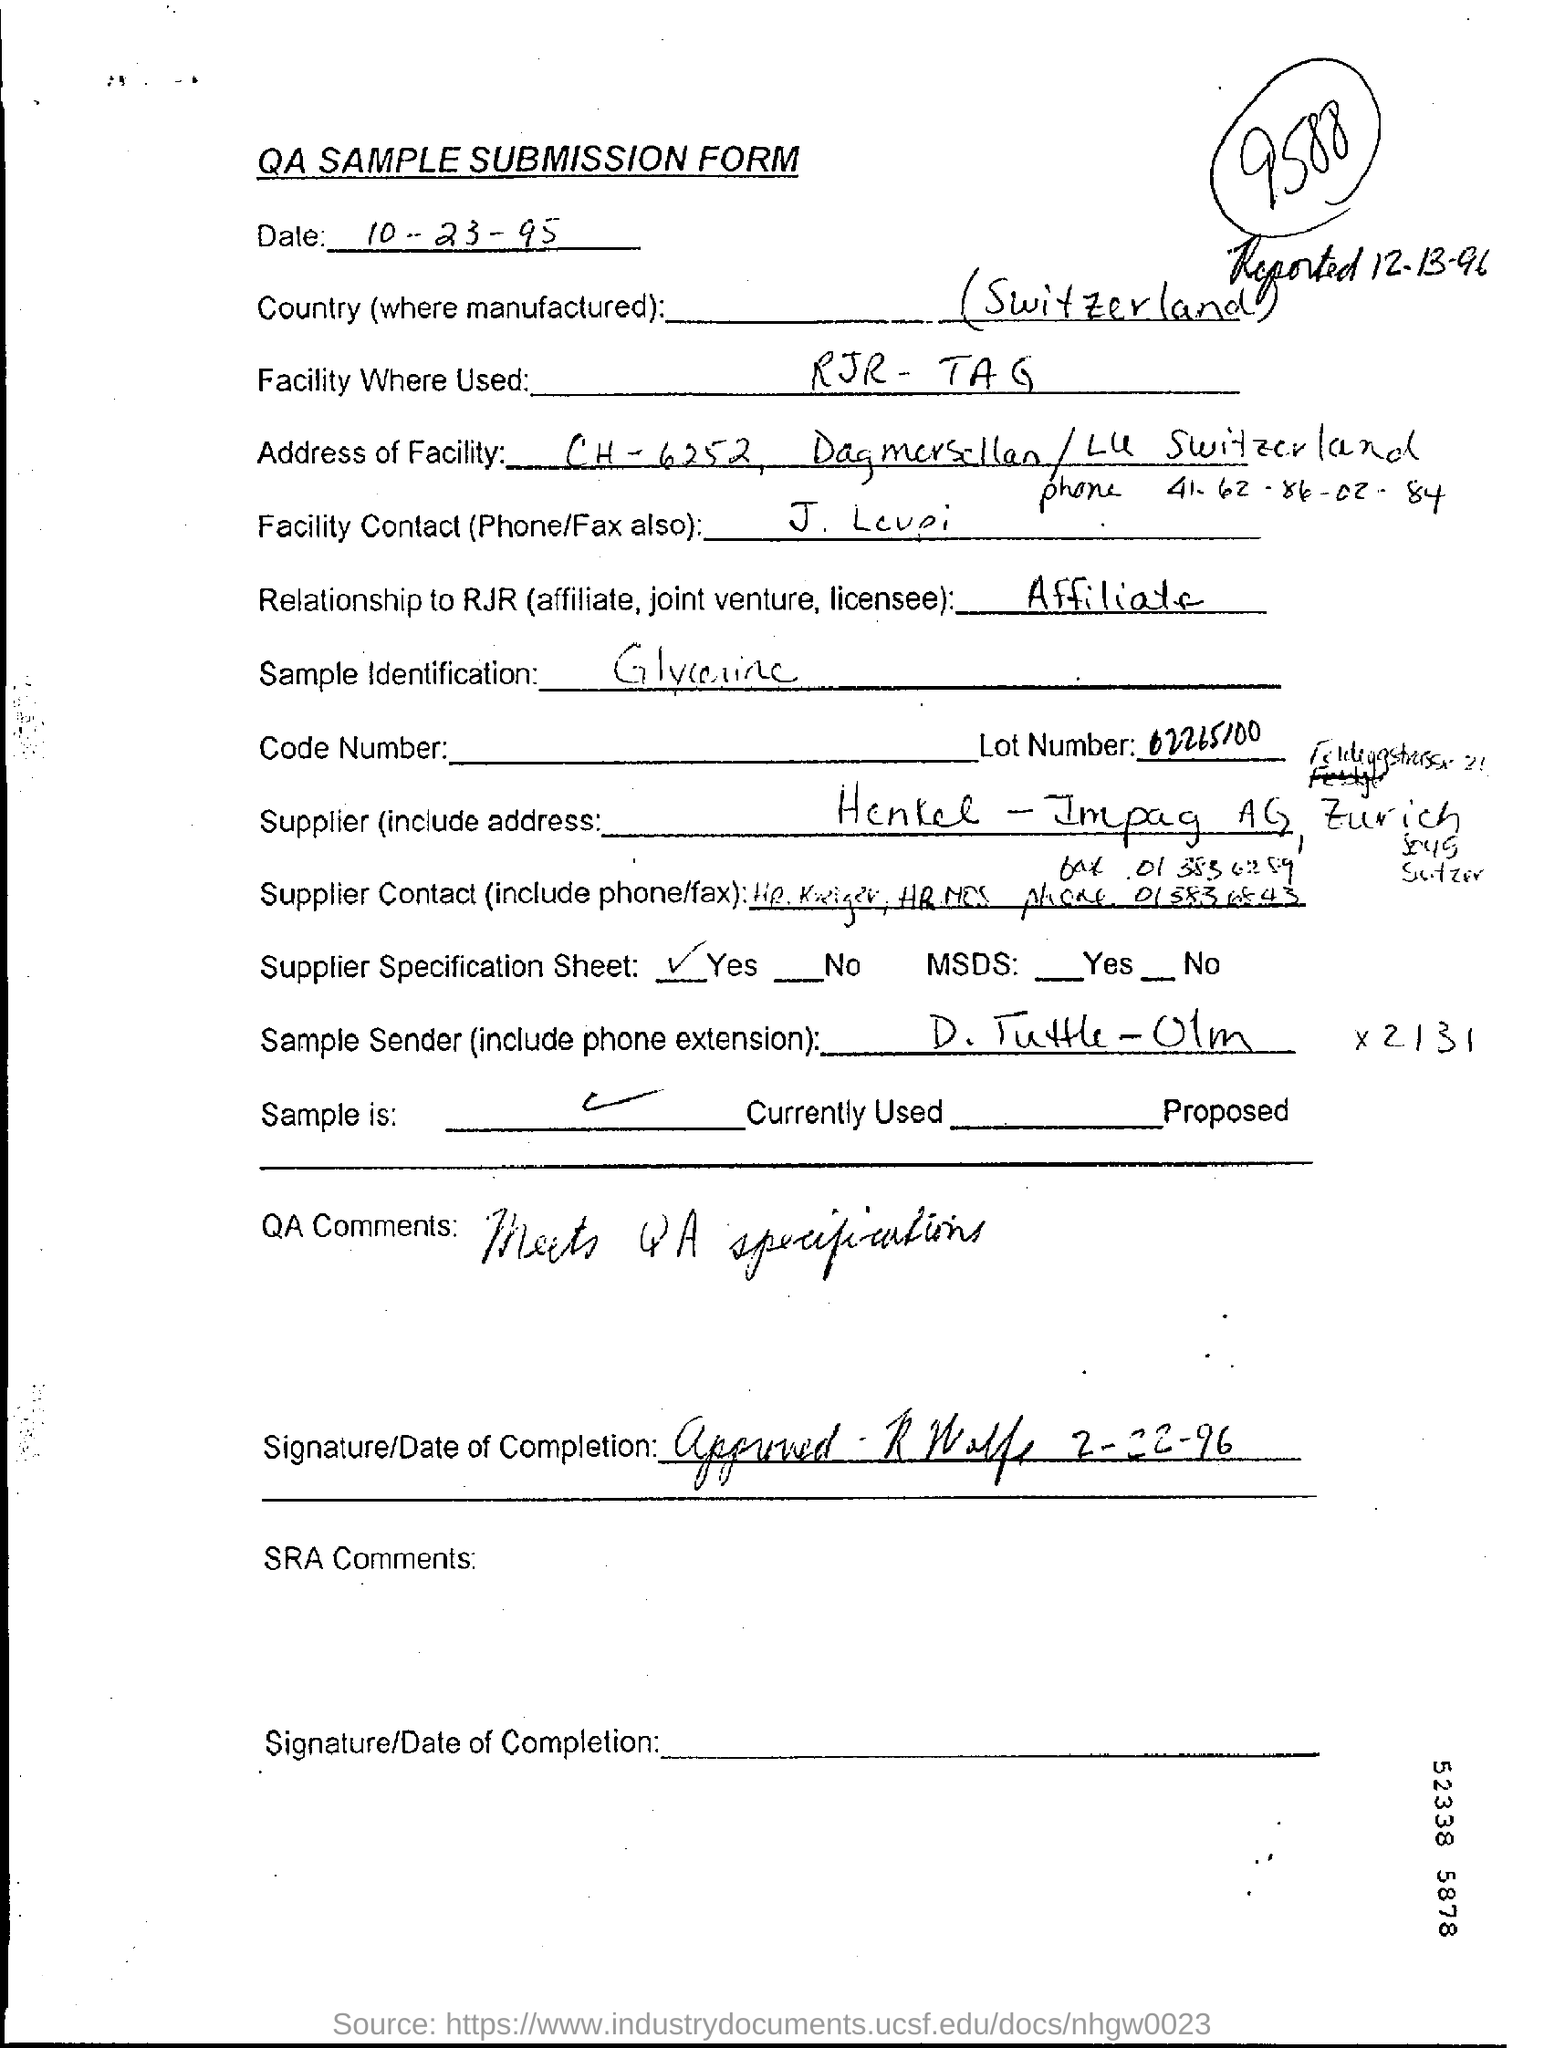Mention a couple of crucial points in this snapshot. For sample identification purposes, glycerine was used. The date in the submission form is 10-23-95. The country where the manufacturing of this product took place is Switzerland. 